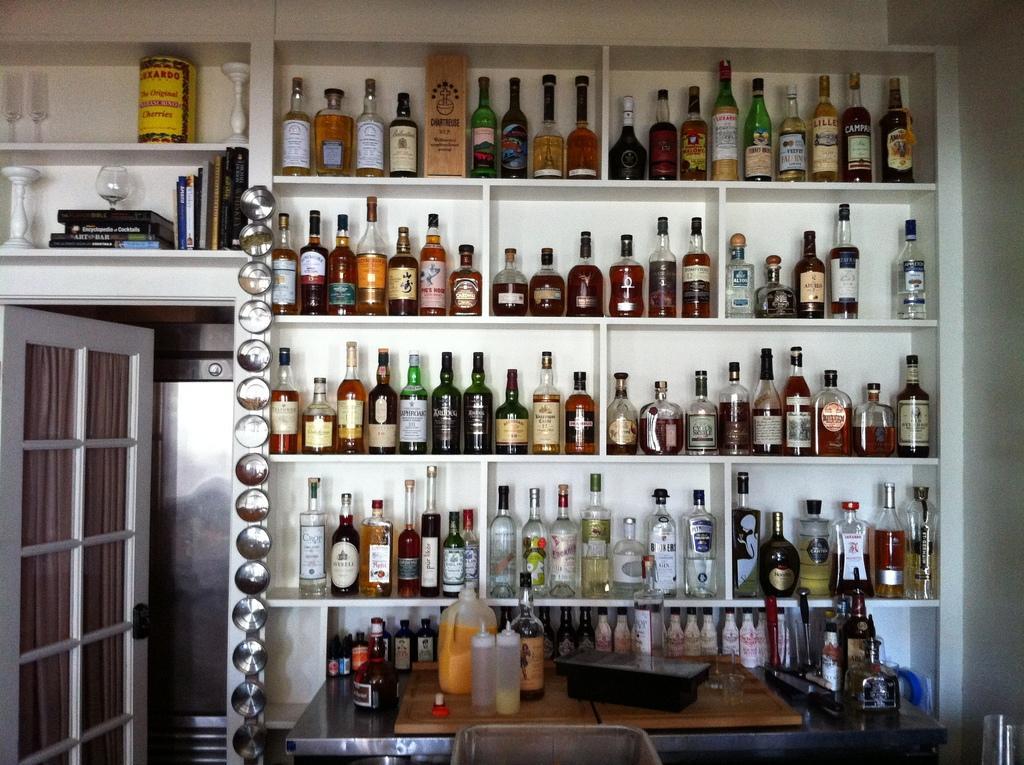Could you give a brief overview of what you see in this image? In this picture we can see bottles in racks and in front of it we have some more bottles, can on table and bedside to this we have door, glass, books in rack. 